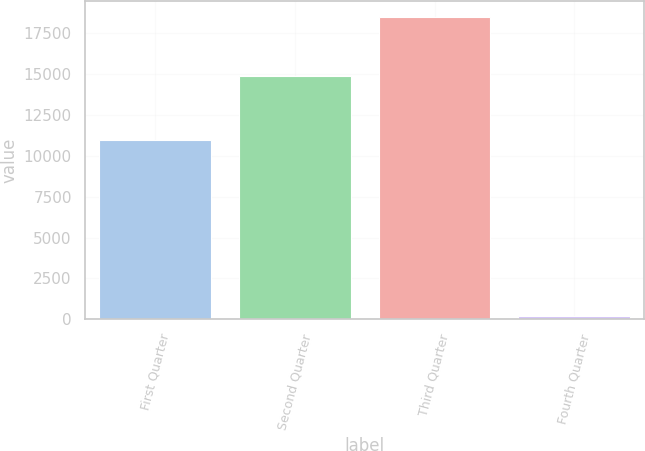Convert chart. <chart><loc_0><loc_0><loc_500><loc_500><bar_chart><fcel>First Quarter<fcel>Second Quarter<fcel>Third Quarter<fcel>Fourth Quarter<nl><fcel>10978<fcel>14882<fcel>18529<fcel>164<nl></chart> 